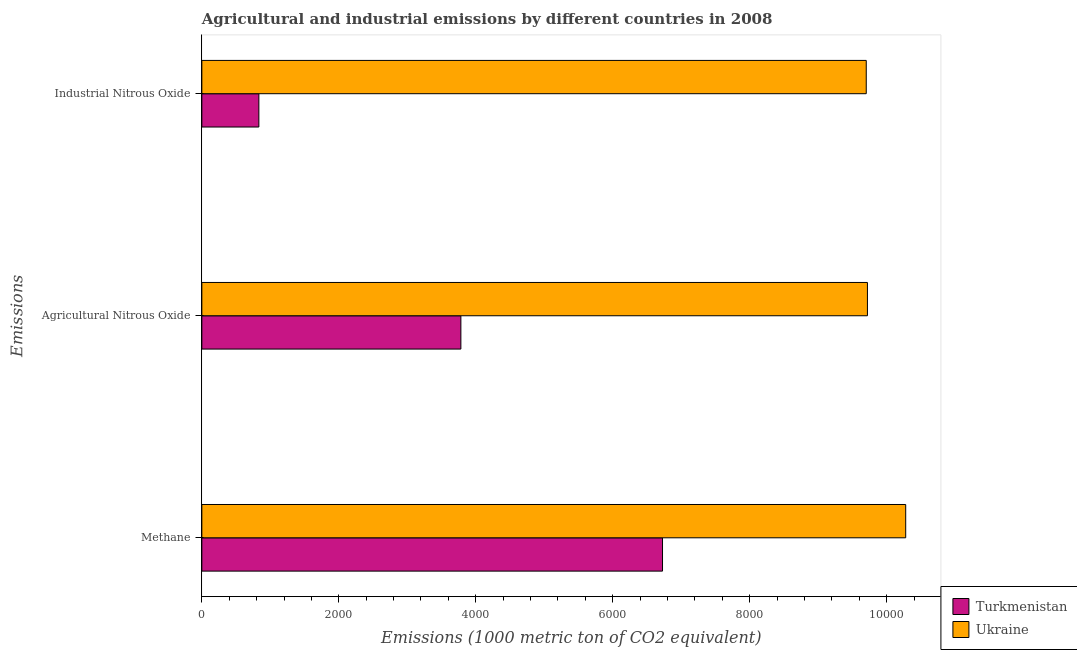How many different coloured bars are there?
Give a very brief answer. 2. How many groups of bars are there?
Make the answer very short. 3. Are the number of bars per tick equal to the number of legend labels?
Make the answer very short. Yes. How many bars are there on the 2nd tick from the top?
Give a very brief answer. 2. How many bars are there on the 2nd tick from the bottom?
Keep it short and to the point. 2. What is the label of the 3rd group of bars from the top?
Ensure brevity in your answer.  Methane. What is the amount of methane emissions in Ukraine?
Your response must be concise. 1.03e+04. Across all countries, what is the maximum amount of agricultural nitrous oxide emissions?
Make the answer very short. 9719.1. Across all countries, what is the minimum amount of methane emissions?
Ensure brevity in your answer.  6726.9. In which country was the amount of industrial nitrous oxide emissions maximum?
Ensure brevity in your answer.  Ukraine. In which country was the amount of agricultural nitrous oxide emissions minimum?
Give a very brief answer. Turkmenistan. What is the total amount of agricultural nitrous oxide emissions in the graph?
Offer a terse response. 1.35e+04. What is the difference between the amount of methane emissions in Turkmenistan and that in Ukraine?
Your answer should be compact. -3551.1. What is the difference between the amount of methane emissions in Turkmenistan and the amount of industrial nitrous oxide emissions in Ukraine?
Ensure brevity in your answer.  -2974.9. What is the average amount of industrial nitrous oxide emissions per country?
Keep it short and to the point. 5267.15. What is the difference between the amount of industrial nitrous oxide emissions and amount of methane emissions in Ukraine?
Provide a succinct answer. -576.2. What is the ratio of the amount of industrial nitrous oxide emissions in Ukraine to that in Turkmenistan?
Give a very brief answer. 11.65. Is the difference between the amount of methane emissions in Ukraine and Turkmenistan greater than the difference between the amount of industrial nitrous oxide emissions in Ukraine and Turkmenistan?
Offer a terse response. No. What is the difference between the highest and the second highest amount of methane emissions?
Keep it short and to the point. 3551.1. What is the difference between the highest and the lowest amount of industrial nitrous oxide emissions?
Provide a short and direct response. 8869.3. In how many countries, is the amount of industrial nitrous oxide emissions greater than the average amount of industrial nitrous oxide emissions taken over all countries?
Keep it short and to the point. 1. Is the sum of the amount of methane emissions in Ukraine and Turkmenistan greater than the maximum amount of agricultural nitrous oxide emissions across all countries?
Offer a very short reply. Yes. What does the 1st bar from the top in Methane represents?
Keep it short and to the point. Ukraine. What does the 2nd bar from the bottom in Agricultural Nitrous Oxide represents?
Offer a very short reply. Ukraine. Is it the case that in every country, the sum of the amount of methane emissions and amount of agricultural nitrous oxide emissions is greater than the amount of industrial nitrous oxide emissions?
Make the answer very short. Yes. How many bars are there?
Make the answer very short. 6. Are all the bars in the graph horizontal?
Your answer should be compact. Yes. What is the difference between two consecutive major ticks on the X-axis?
Your answer should be very brief. 2000. Does the graph contain grids?
Ensure brevity in your answer.  No. Where does the legend appear in the graph?
Keep it short and to the point. Bottom right. What is the title of the graph?
Your answer should be compact. Agricultural and industrial emissions by different countries in 2008. Does "Mongolia" appear as one of the legend labels in the graph?
Offer a very short reply. No. What is the label or title of the X-axis?
Your response must be concise. Emissions (1000 metric ton of CO2 equivalent). What is the label or title of the Y-axis?
Make the answer very short. Emissions. What is the Emissions (1000 metric ton of CO2 equivalent) in Turkmenistan in Methane?
Offer a very short reply. 6726.9. What is the Emissions (1000 metric ton of CO2 equivalent) of Ukraine in Methane?
Give a very brief answer. 1.03e+04. What is the Emissions (1000 metric ton of CO2 equivalent) in Turkmenistan in Agricultural Nitrous Oxide?
Provide a short and direct response. 3782.4. What is the Emissions (1000 metric ton of CO2 equivalent) of Ukraine in Agricultural Nitrous Oxide?
Your answer should be compact. 9719.1. What is the Emissions (1000 metric ton of CO2 equivalent) of Turkmenistan in Industrial Nitrous Oxide?
Offer a very short reply. 832.5. What is the Emissions (1000 metric ton of CO2 equivalent) in Ukraine in Industrial Nitrous Oxide?
Make the answer very short. 9701.8. Across all Emissions, what is the maximum Emissions (1000 metric ton of CO2 equivalent) of Turkmenistan?
Your answer should be compact. 6726.9. Across all Emissions, what is the maximum Emissions (1000 metric ton of CO2 equivalent) of Ukraine?
Provide a succinct answer. 1.03e+04. Across all Emissions, what is the minimum Emissions (1000 metric ton of CO2 equivalent) of Turkmenistan?
Provide a succinct answer. 832.5. Across all Emissions, what is the minimum Emissions (1000 metric ton of CO2 equivalent) of Ukraine?
Provide a succinct answer. 9701.8. What is the total Emissions (1000 metric ton of CO2 equivalent) of Turkmenistan in the graph?
Make the answer very short. 1.13e+04. What is the total Emissions (1000 metric ton of CO2 equivalent) of Ukraine in the graph?
Your response must be concise. 2.97e+04. What is the difference between the Emissions (1000 metric ton of CO2 equivalent) in Turkmenistan in Methane and that in Agricultural Nitrous Oxide?
Your answer should be compact. 2944.5. What is the difference between the Emissions (1000 metric ton of CO2 equivalent) in Ukraine in Methane and that in Agricultural Nitrous Oxide?
Keep it short and to the point. 558.9. What is the difference between the Emissions (1000 metric ton of CO2 equivalent) in Turkmenistan in Methane and that in Industrial Nitrous Oxide?
Your answer should be very brief. 5894.4. What is the difference between the Emissions (1000 metric ton of CO2 equivalent) of Ukraine in Methane and that in Industrial Nitrous Oxide?
Offer a terse response. 576.2. What is the difference between the Emissions (1000 metric ton of CO2 equivalent) of Turkmenistan in Agricultural Nitrous Oxide and that in Industrial Nitrous Oxide?
Ensure brevity in your answer.  2949.9. What is the difference between the Emissions (1000 metric ton of CO2 equivalent) in Ukraine in Agricultural Nitrous Oxide and that in Industrial Nitrous Oxide?
Your answer should be very brief. 17.3. What is the difference between the Emissions (1000 metric ton of CO2 equivalent) of Turkmenistan in Methane and the Emissions (1000 metric ton of CO2 equivalent) of Ukraine in Agricultural Nitrous Oxide?
Your answer should be compact. -2992.2. What is the difference between the Emissions (1000 metric ton of CO2 equivalent) in Turkmenistan in Methane and the Emissions (1000 metric ton of CO2 equivalent) in Ukraine in Industrial Nitrous Oxide?
Offer a terse response. -2974.9. What is the difference between the Emissions (1000 metric ton of CO2 equivalent) in Turkmenistan in Agricultural Nitrous Oxide and the Emissions (1000 metric ton of CO2 equivalent) in Ukraine in Industrial Nitrous Oxide?
Offer a very short reply. -5919.4. What is the average Emissions (1000 metric ton of CO2 equivalent) in Turkmenistan per Emissions?
Your answer should be very brief. 3780.6. What is the average Emissions (1000 metric ton of CO2 equivalent) of Ukraine per Emissions?
Provide a short and direct response. 9899.63. What is the difference between the Emissions (1000 metric ton of CO2 equivalent) of Turkmenistan and Emissions (1000 metric ton of CO2 equivalent) of Ukraine in Methane?
Offer a terse response. -3551.1. What is the difference between the Emissions (1000 metric ton of CO2 equivalent) of Turkmenistan and Emissions (1000 metric ton of CO2 equivalent) of Ukraine in Agricultural Nitrous Oxide?
Offer a terse response. -5936.7. What is the difference between the Emissions (1000 metric ton of CO2 equivalent) of Turkmenistan and Emissions (1000 metric ton of CO2 equivalent) of Ukraine in Industrial Nitrous Oxide?
Your response must be concise. -8869.3. What is the ratio of the Emissions (1000 metric ton of CO2 equivalent) of Turkmenistan in Methane to that in Agricultural Nitrous Oxide?
Provide a succinct answer. 1.78. What is the ratio of the Emissions (1000 metric ton of CO2 equivalent) in Ukraine in Methane to that in Agricultural Nitrous Oxide?
Your answer should be compact. 1.06. What is the ratio of the Emissions (1000 metric ton of CO2 equivalent) in Turkmenistan in Methane to that in Industrial Nitrous Oxide?
Provide a succinct answer. 8.08. What is the ratio of the Emissions (1000 metric ton of CO2 equivalent) of Ukraine in Methane to that in Industrial Nitrous Oxide?
Give a very brief answer. 1.06. What is the ratio of the Emissions (1000 metric ton of CO2 equivalent) of Turkmenistan in Agricultural Nitrous Oxide to that in Industrial Nitrous Oxide?
Offer a terse response. 4.54. What is the ratio of the Emissions (1000 metric ton of CO2 equivalent) in Ukraine in Agricultural Nitrous Oxide to that in Industrial Nitrous Oxide?
Provide a succinct answer. 1. What is the difference between the highest and the second highest Emissions (1000 metric ton of CO2 equivalent) of Turkmenistan?
Offer a very short reply. 2944.5. What is the difference between the highest and the second highest Emissions (1000 metric ton of CO2 equivalent) in Ukraine?
Make the answer very short. 558.9. What is the difference between the highest and the lowest Emissions (1000 metric ton of CO2 equivalent) of Turkmenistan?
Your answer should be compact. 5894.4. What is the difference between the highest and the lowest Emissions (1000 metric ton of CO2 equivalent) in Ukraine?
Give a very brief answer. 576.2. 